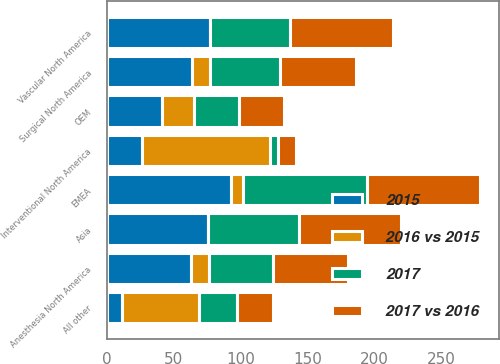Convert chart. <chart><loc_0><loc_0><loc_500><loc_500><stacked_bar_chart><ecel><fcel>Vascular North America<fcel>Interventional North America<fcel>Anesthesia North America<fcel>Surgical North America<fcel>EMEA<fcel>Asia<fcel>OEM<fcel>All other<nl><fcel>2015<fcel>77<fcel>26<fcel>62.9<fcel>63.9<fcel>92.4<fcel>75.6<fcel>41.6<fcel>11.2<nl><fcel>2017 vs 2016<fcel>77.1<fcel>13.3<fcel>55.6<fcel>56.6<fcel>84.4<fcel>75.7<fcel>33.6<fcel>26.5<nl><fcel>2017<fcel>59.5<fcel>5.8<fcel>48.3<fcel>52.5<fcel>92.3<fcel>67.9<fcel>33.2<fcel>28.4<nl><fcel>2016 vs 2015<fcel>0.1<fcel>95.8<fcel>13.2<fcel>12.9<fcel>9.5<fcel>0.2<fcel>23.6<fcel>57.9<nl></chart> 